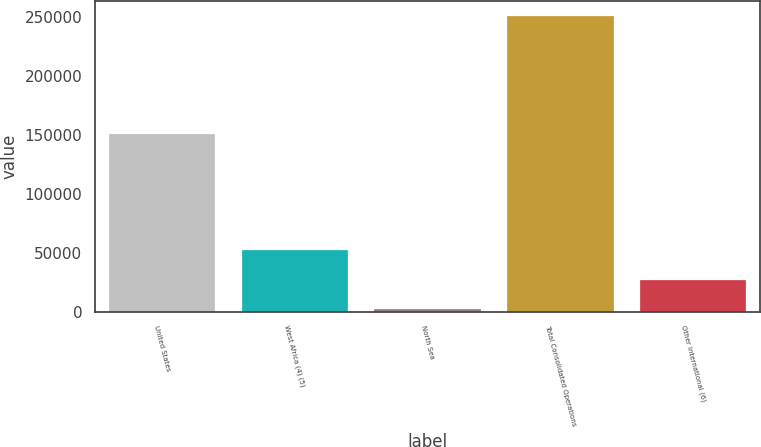Convert chart to OTSL. <chart><loc_0><loc_0><loc_500><loc_500><bar_chart><fcel>United States<fcel>West Africa (4) (5)<fcel>North Sea<fcel>Total Consolidated Operations<fcel>Other International (6)<nl><fcel>150457<fcel>52004<fcel>2276<fcel>250916<fcel>27140<nl></chart> 